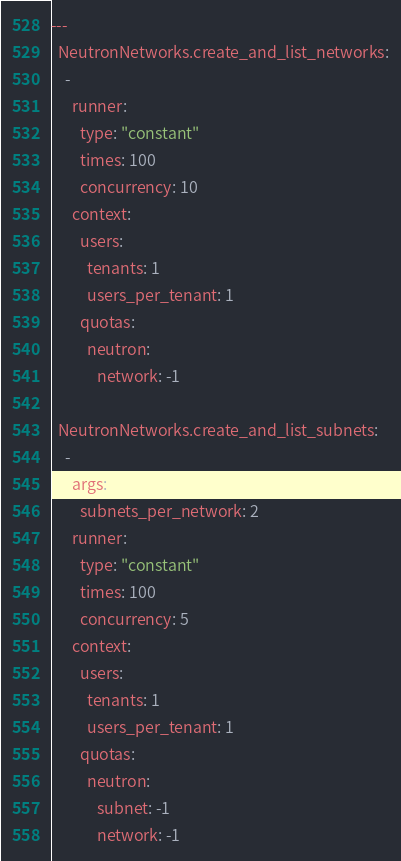<code> <loc_0><loc_0><loc_500><loc_500><_YAML_>---
  NeutronNetworks.create_and_list_networks:
    -
      runner:
        type: "constant"
        times: 100
        concurrency: 10
      context:
        users:
          tenants: 1
          users_per_tenant: 1
        quotas:
          neutron:
             network: -1

  NeutronNetworks.create_and_list_subnets:
    -
      args:
        subnets_per_network: 2
      runner:
        type: "constant"
        times: 100
        concurrency: 5
      context:
        users:
          tenants: 1
          users_per_tenant: 1
        quotas:
          neutron:
             subnet: -1
             network: -1
</code> 